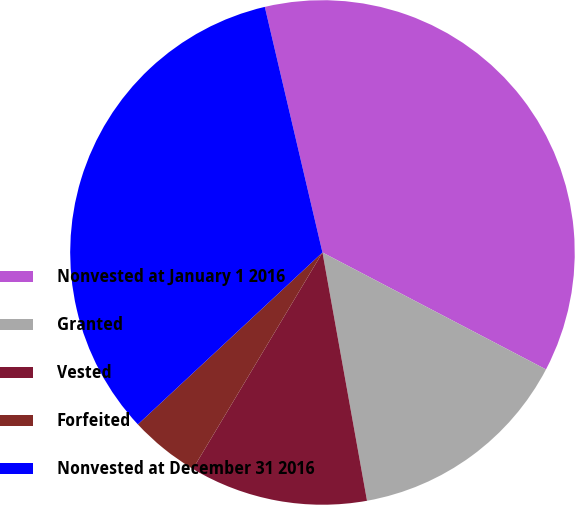Convert chart. <chart><loc_0><loc_0><loc_500><loc_500><pie_chart><fcel>Nonvested at January 1 2016<fcel>Granted<fcel>Vested<fcel>Forfeited<fcel>Nonvested at December 31 2016<nl><fcel>36.34%<fcel>14.5%<fcel>11.41%<fcel>4.48%<fcel>33.26%<nl></chart> 